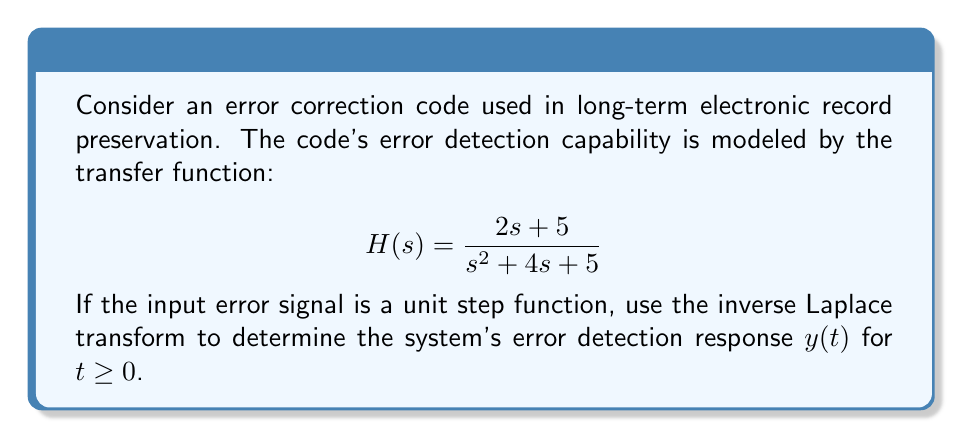Show me your answer to this math problem. 1) First, we need to find Y(s), which is the product of H(s) and the Laplace transform of the unit step function (1/s):

   $$Y(s) = H(s) \cdot \frac{1}{s} = \frac{2s + 5}{s^2 + 4s + 5} \cdot \frac{1}{s} = \frac{2s + 5}{s(s^2 + 4s + 5)}$$

2) To find the inverse Laplace transform, we need to decompose this into partial fractions:

   $$\frac{2s + 5}{s(s^2 + 4s + 5)} = \frac{A}{s} + \frac{Bs + C}{s^2 + 4s + 5}$$

3) Solving for A, B, and C:
   
   $A = 1$
   $B = 1$
   $C = -1$

4) So, we have:

   $$Y(s) = \frac{1}{s} + \frac{s - 1}{s^2 + 4s + 5}$$

5) Now, we can use known Laplace transform pairs:

   $\mathcal{L}^{-1}\{\frac{1}{s}\} = 1$
   
   $\mathcal{L}^{-1}\{\frac{s}{s^2 + 4s + 5}\} = e^{-2t}\cos(t)$
   
   $\mathcal{L}^{-1}\{\frac{1}{s^2 + 4s + 5}\} = e^{-2t}\sin(t)$

6) Applying the inverse Laplace transform:

   $$y(t) = 1 + e^{-2t}\cos(t) - e^{-2t}\sin(t)$$

7) This can be simplified using trigonometric identities:

   $$y(t) = 1 + \sqrt{2}e^{-2t}\cos(t + \frac{\pi}{4})$$

This is the error detection response of the system for t ≥ 0.
Answer: $y(t) = 1 + \sqrt{2}e^{-2t}\cos(t + \frac{\pi}{4})$ for t ≥ 0 